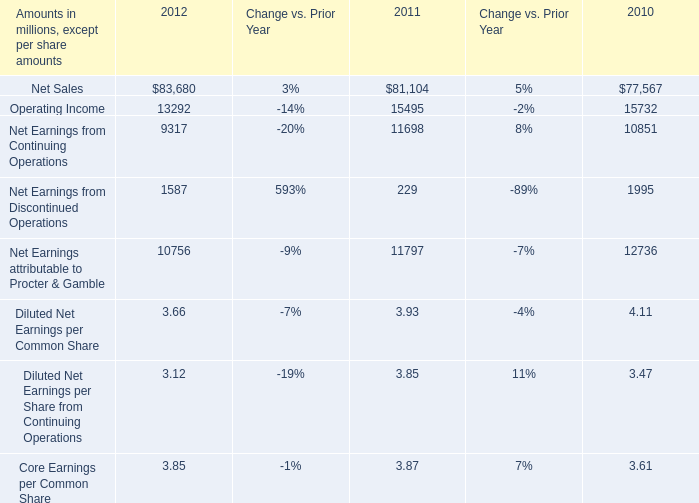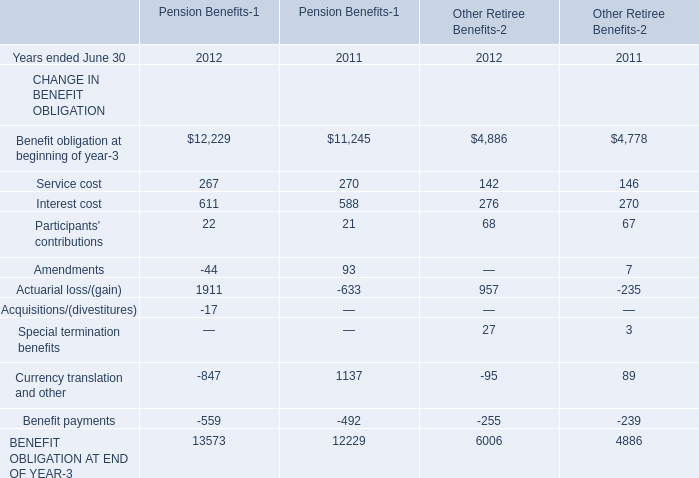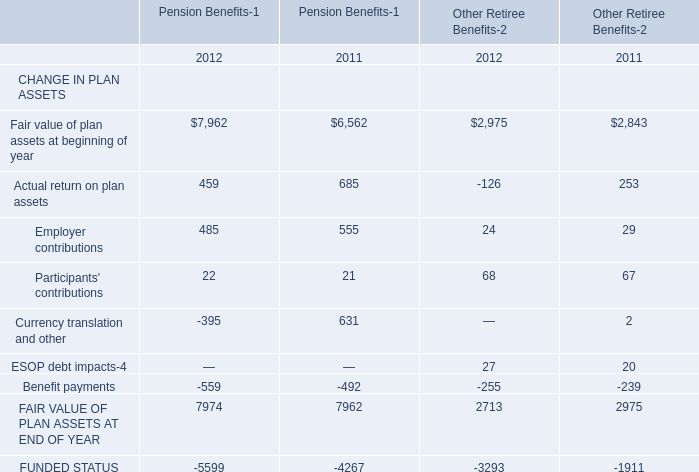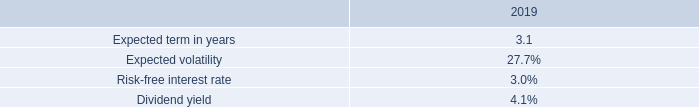In the year with lowest amount of service cost for pension benefits, what's the increasing rate of Participants' contributions for pension benefits? 
Computations: ((22 - 21) / 21)
Answer: 0.04762. 